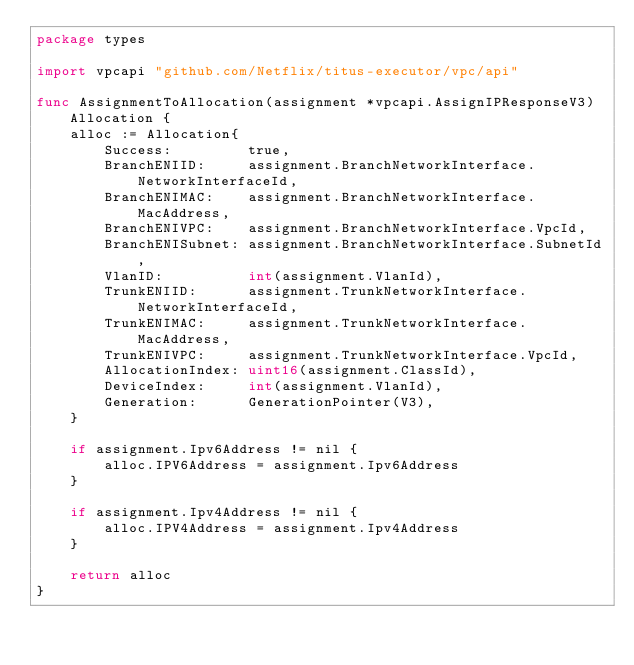<code> <loc_0><loc_0><loc_500><loc_500><_Go_>package types

import vpcapi "github.com/Netflix/titus-executor/vpc/api"

func AssignmentToAllocation(assignment *vpcapi.AssignIPResponseV3) Allocation {
	alloc := Allocation{
		Success:         true,
		BranchENIID:     assignment.BranchNetworkInterface.NetworkInterfaceId,
		BranchENIMAC:    assignment.BranchNetworkInterface.MacAddress,
		BranchENIVPC:    assignment.BranchNetworkInterface.VpcId,
		BranchENISubnet: assignment.BranchNetworkInterface.SubnetId,
		VlanID:          int(assignment.VlanId),
		TrunkENIID:      assignment.TrunkNetworkInterface.NetworkInterfaceId,
		TrunkENIMAC:     assignment.TrunkNetworkInterface.MacAddress,
		TrunkENIVPC:     assignment.TrunkNetworkInterface.VpcId,
		AllocationIndex: uint16(assignment.ClassId),
		DeviceIndex:     int(assignment.VlanId),
		Generation:      GenerationPointer(V3),
	}

	if assignment.Ipv6Address != nil {
		alloc.IPV6Address = assignment.Ipv6Address
	}

	if assignment.Ipv4Address != nil {
		alloc.IPV4Address = assignment.Ipv4Address
	}

	return alloc
}
</code> 